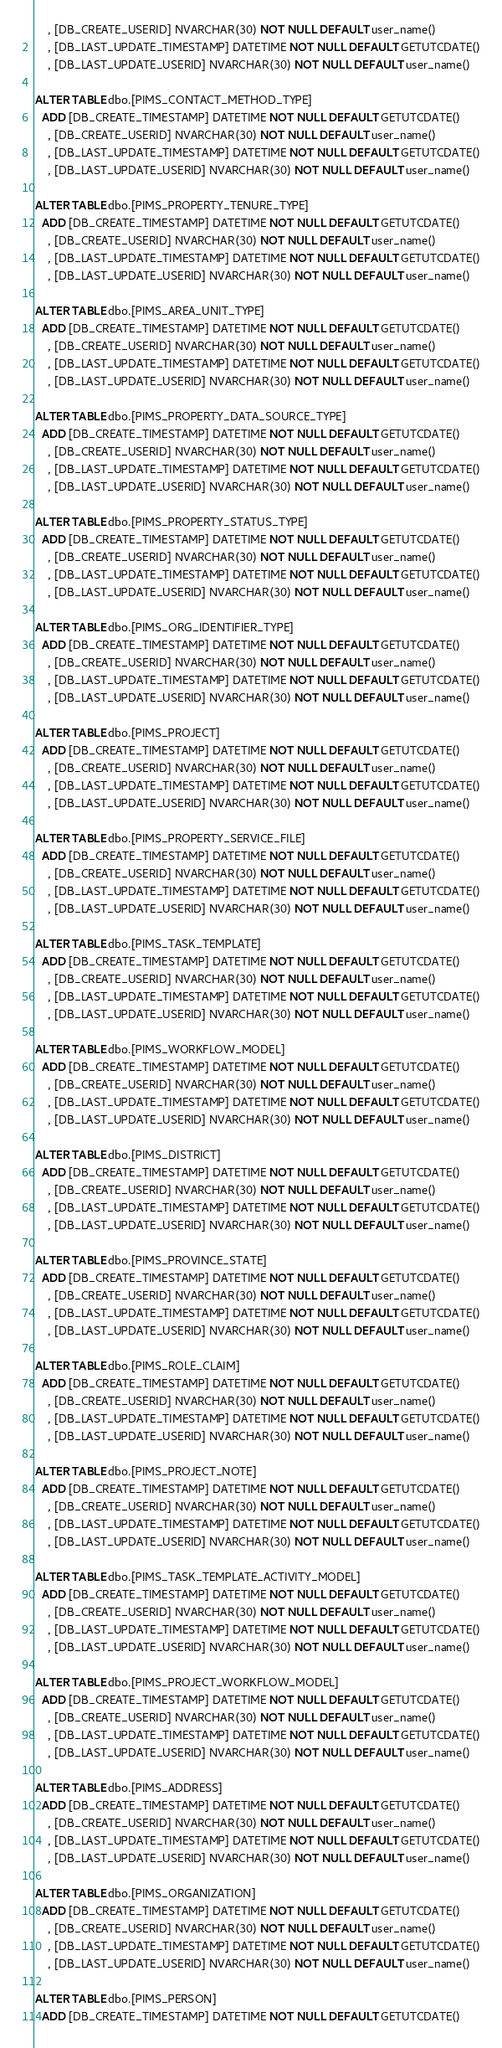Convert code to text. <code><loc_0><loc_0><loc_500><loc_500><_SQL_>    , [DB_CREATE_USERID] NVARCHAR(30) NOT NULL DEFAULT user_name()
    , [DB_LAST_UPDATE_TIMESTAMP] DATETIME NOT NULL DEFAULT GETUTCDATE()
    , [DB_LAST_UPDATE_USERID] NVARCHAR(30) NOT NULL DEFAULT user_name()

ALTER TABLE dbo.[PIMS_CONTACT_METHOD_TYPE]
  ADD [DB_CREATE_TIMESTAMP] DATETIME NOT NULL DEFAULT GETUTCDATE()
    , [DB_CREATE_USERID] NVARCHAR(30) NOT NULL DEFAULT user_name()
    , [DB_LAST_UPDATE_TIMESTAMP] DATETIME NOT NULL DEFAULT GETUTCDATE()
    , [DB_LAST_UPDATE_USERID] NVARCHAR(30) NOT NULL DEFAULT user_name()

ALTER TABLE dbo.[PIMS_PROPERTY_TENURE_TYPE]
  ADD [DB_CREATE_TIMESTAMP] DATETIME NOT NULL DEFAULT GETUTCDATE()
    , [DB_CREATE_USERID] NVARCHAR(30) NOT NULL DEFAULT user_name()
    , [DB_LAST_UPDATE_TIMESTAMP] DATETIME NOT NULL DEFAULT GETUTCDATE()
    , [DB_LAST_UPDATE_USERID] NVARCHAR(30) NOT NULL DEFAULT user_name()

ALTER TABLE dbo.[PIMS_AREA_UNIT_TYPE]
  ADD [DB_CREATE_TIMESTAMP] DATETIME NOT NULL DEFAULT GETUTCDATE()
    , [DB_CREATE_USERID] NVARCHAR(30) NOT NULL DEFAULT user_name()
    , [DB_LAST_UPDATE_TIMESTAMP] DATETIME NOT NULL DEFAULT GETUTCDATE()
    , [DB_LAST_UPDATE_USERID] NVARCHAR(30) NOT NULL DEFAULT user_name()

ALTER TABLE dbo.[PIMS_PROPERTY_DATA_SOURCE_TYPE]
  ADD [DB_CREATE_TIMESTAMP] DATETIME NOT NULL DEFAULT GETUTCDATE()
    , [DB_CREATE_USERID] NVARCHAR(30) NOT NULL DEFAULT user_name()
    , [DB_LAST_UPDATE_TIMESTAMP] DATETIME NOT NULL DEFAULT GETUTCDATE()
    , [DB_LAST_UPDATE_USERID] NVARCHAR(30) NOT NULL DEFAULT user_name()

ALTER TABLE dbo.[PIMS_PROPERTY_STATUS_TYPE]
  ADD [DB_CREATE_TIMESTAMP] DATETIME NOT NULL DEFAULT GETUTCDATE()
    , [DB_CREATE_USERID] NVARCHAR(30) NOT NULL DEFAULT user_name()
    , [DB_LAST_UPDATE_TIMESTAMP] DATETIME NOT NULL DEFAULT GETUTCDATE()
    , [DB_LAST_UPDATE_USERID] NVARCHAR(30) NOT NULL DEFAULT user_name()

ALTER TABLE dbo.[PIMS_ORG_IDENTIFIER_TYPE]
  ADD [DB_CREATE_TIMESTAMP] DATETIME NOT NULL DEFAULT GETUTCDATE()
    , [DB_CREATE_USERID] NVARCHAR(30) NOT NULL DEFAULT user_name()
    , [DB_LAST_UPDATE_TIMESTAMP] DATETIME NOT NULL DEFAULT GETUTCDATE()
    , [DB_LAST_UPDATE_USERID] NVARCHAR(30) NOT NULL DEFAULT user_name()

ALTER TABLE dbo.[PIMS_PROJECT]
  ADD [DB_CREATE_TIMESTAMP] DATETIME NOT NULL DEFAULT GETUTCDATE()
    , [DB_CREATE_USERID] NVARCHAR(30) NOT NULL DEFAULT user_name()
    , [DB_LAST_UPDATE_TIMESTAMP] DATETIME NOT NULL DEFAULT GETUTCDATE()
    , [DB_LAST_UPDATE_USERID] NVARCHAR(30) NOT NULL DEFAULT user_name()

ALTER TABLE dbo.[PIMS_PROPERTY_SERVICE_FILE]
  ADD [DB_CREATE_TIMESTAMP] DATETIME NOT NULL DEFAULT GETUTCDATE()
    , [DB_CREATE_USERID] NVARCHAR(30) NOT NULL DEFAULT user_name()
    , [DB_LAST_UPDATE_TIMESTAMP] DATETIME NOT NULL DEFAULT GETUTCDATE()
    , [DB_LAST_UPDATE_USERID] NVARCHAR(30) NOT NULL DEFAULT user_name()

ALTER TABLE dbo.[PIMS_TASK_TEMPLATE]
  ADD [DB_CREATE_TIMESTAMP] DATETIME NOT NULL DEFAULT GETUTCDATE()
    , [DB_CREATE_USERID] NVARCHAR(30) NOT NULL DEFAULT user_name()
    , [DB_LAST_UPDATE_TIMESTAMP] DATETIME NOT NULL DEFAULT GETUTCDATE()
    , [DB_LAST_UPDATE_USERID] NVARCHAR(30) NOT NULL DEFAULT user_name()

ALTER TABLE dbo.[PIMS_WORKFLOW_MODEL]
  ADD [DB_CREATE_TIMESTAMP] DATETIME NOT NULL DEFAULT GETUTCDATE()
    , [DB_CREATE_USERID] NVARCHAR(30) NOT NULL DEFAULT user_name()
    , [DB_LAST_UPDATE_TIMESTAMP] DATETIME NOT NULL DEFAULT GETUTCDATE()
    , [DB_LAST_UPDATE_USERID] NVARCHAR(30) NOT NULL DEFAULT user_name()

ALTER TABLE dbo.[PIMS_DISTRICT]
  ADD [DB_CREATE_TIMESTAMP] DATETIME NOT NULL DEFAULT GETUTCDATE()
    , [DB_CREATE_USERID] NVARCHAR(30) NOT NULL DEFAULT user_name()
    , [DB_LAST_UPDATE_TIMESTAMP] DATETIME NOT NULL DEFAULT GETUTCDATE()
    , [DB_LAST_UPDATE_USERID] NVARCHAR(30) NOT NULL DEFAULT user_name()

ALTER TABLE dbo.[PIMS_PROVINCE_STATE]
  ADD [DB_CREATE_TIMESTAMP] DATETIME NOT NULL DEFAULT GETUTCDATE()
    , [DB_CREATE_USERID] NVARCHAR(30) NOT NULL DEFAULT user_name()
    , [DB_LAST_UPDATE_TIMESTAMP] DATETIME NOT NULL DEFAULT GETUTCDATE()
    , [DB_LAST_UPDATE_USERID] NVARCHAR(30) NOT NULL DEFAULT user_name()

ALTER TABLE dbo.[PIMS_ROLE_CLAIM]
  ADD [DB_CREATE_TIMESTAMP] DATETIME NOT NULL DEFAULT GETUTCDATE()
    , [DB_CREATE_USERID] NVARCHAR(30) NOT NULL DEFAULT user_name()
    , [DB_LAST_UPDATE_TIMESTAMP] DATETIME NOT NULL DEFAULT GETUTCDATE()
    , [DB_LAST_UPDATE_USERID] NVARCHAR(30) NOT NULL DEFAULT user_name()

ALTER TABLE dbo.[PIMS_PROJECT_NOTE]
  ADD [DB_CREATE_TIMESTAMP] DATETIME NOT NULL DEFAULT GETUTCDATE()
    , [DB_CREATE_USERID] NVARCHAR(30) NOT NULL DEFAULT user_name()
    , [DB_LAST_UPDATE_TIMESTAMP] DATETIME NOT NULL DEFAULT GETUTCDATE()
    , [DB_LAST_UPDATE_USERID] NVARCHAR(30) NOT NULL DEFAULT user_name()

ALTER TABLE dbo.[PIMS_TASK_TEMPLATE_ACTIVITY_MODEL]
  ADD [DB_CREATE_TIMESTAMP] DATETIME NOT NULL DEFAULT GETUTCDATE()
    , [DB_CREATE_USERID] NVARCHAR(30) NOT NULL DEFAULT user_name()
    , [DB_LAST_UPDATE_TIMESTAMP] DATETIME NOT NULL DEFAULT GETUTCDATE()
    , [DB_LAST_UPDATE_USERID] NVARCHAR(30) NOT NULL DEFAULT user_name()

ALTER TABLE dbo.[PIMS_PROJECT_WORKFLOW_MODEL]
  ADD [DB_CREATE_TIMESTAMP] DATETIME NOT NULL DEFAULT GETUTCDATE()
    , [DB_CREATE_USERID] NVARCHAR(30) NOT NULL DEFAULT user_name()
    , [DB_LAST_UPDATE_TIMESTAMP] DATETIME NOT NULL DEFAULT GETUTCDATE()
    , [DB_LAST_UPDATE_USERID] NVARCHAR(30) NOT NULL DEFAULT user_name()

ALTER TABLE dbo.[PIMS_ADDRESS]
  ADD [DB_CREATE_TIMESTAMP] DATETIME NOT NULL DEFAULT GETUTCDATE()
    , [DB_CREATE_USERID] NVARCHAR(30) NOT NULL DEFAULT user_name()
    , [DB_LAST_UPDATE_TIMESTAMP] DATETIME NOT NULL DEFAULT GETUTCDATE()
    , [DB_LAST_UPDATE_USERID] NVARCHAR(30) NOT NULL DEFAULT user_name()

ALTER TABLE dbo.[PIMS_ORGANIZATION]
  ADD [DB_CREATE_TIMESTAMP] DATETIME NOT NULL DEFAULT GETUTCDATE()
    , [DB_CREATE_USERID] NVARCHAR(30) NOT NULL DEFAULT user_name()
    , [DB_LAST_UPDATE_TIMESTAMP] DATETIME NOT NULL DEFAULT GETUTCDATE()
    , [DB_LAST_UPDATE_USERID] NVARCHAR(30) NOT NULL DEFAULT user_name()

ALTER TABLE dbo.[PIMS_PERSON]
  ADD [DB_CREATE_TIMESTAMP] DATETIME NOT NULL DEFAULT GETUTCDATE()</code> 